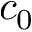Convert formula to latex. <formula><loc_0><loc_0><loc_500><loc_500>c _ { 0 }</formula> 